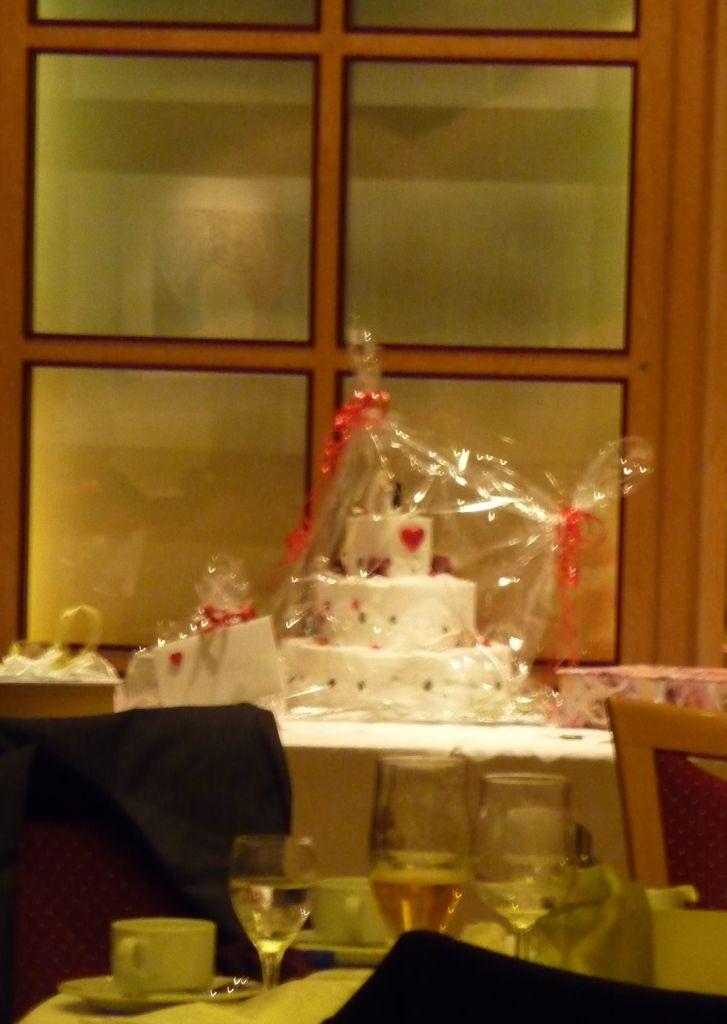Describe this image in one or two sentences. In this picture we can see a cake on the table. This is the chair. And there are some glasses and cups on the table. 